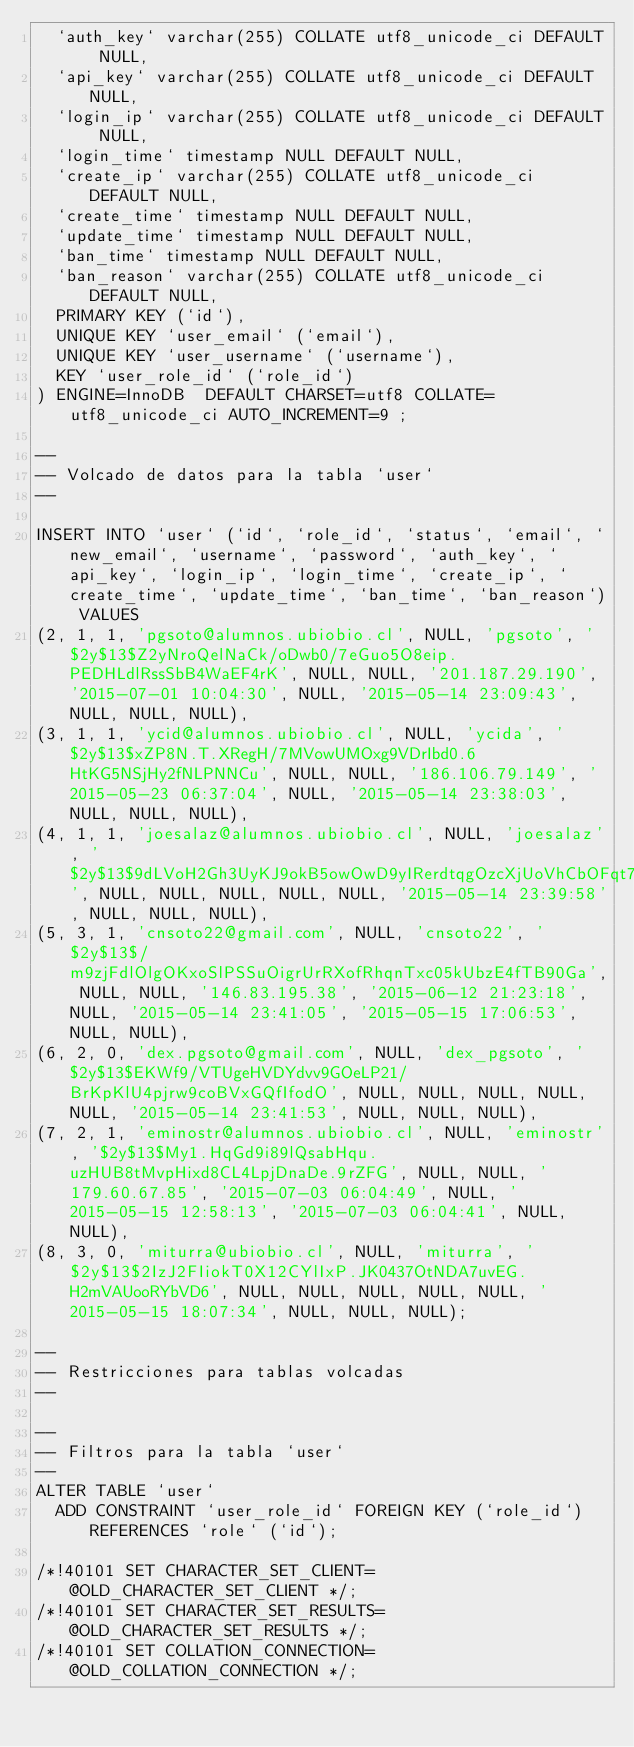Convert code to text. <code><loc_0><loc_0><loc_500><loc_500><_SQL_>  `auth_key` varchar(255) COLLATE utf8_unicode_ci DEFAULT NULL,
  `api_key` varchar(255) COLLATE utf8_unicode_ci DEFAULT NULL,
  `login_ip` varchar(255) COLLATE utf8_unicode_ci DEFAULT NULL,
  `login_time` timestamp NULL DEFAULT NULL,
  `create_ip` varchar(255) COLLATE utf8_unicode_ci DEFAULT NULL,
  `create_time` timestamp NULL DEFAULT NULL,
  `update_time` timestamp NULL DEFAULT NULL,
  `ban_time` timestamp NULL DEFAULT NULL,
  `ban_reason` varchar(255) COLLATE utf8_unicode_ci DEFAULT NULL,
  PRIMARY KEY (`id`),
  UNIQUE KEY `user_email` (`email`),
  UNIQUE KEY `user_username` (`username`),
  KEY `user_role_id` (`role_id`)
) ENGINE=InnoDB  DEFAULT CHARSET=utf8 COLLATE=utf8_unicode_ci AUTO_INCREMENT=9 ;

--
-- Volcado de datos para la tabla `user`
--

INSERT INTO `user` (`id`, `role_id`, `status`, `email`, `new_email`, `username`, `password`, `auth_key`, `api_key`, `login_ip`, `login_time`, `create_ip`, `create_time`, `update_time`, `ban_time`, `ban_reason`) VALUES
(2, 1, 1, 'pgsoto@alumnos.ubiobio.cl', NULL, 'pgsoto', '$2y$13$Z2yNroQelNaCk/oDwb0/7eGuo5O8eip.PEDHLdlRssSbB4WaEF4rK', NULL, NULL, '201.187.29.190', '2015-07-01 10:04:30', NULL, '2015-05-14 23:09:43', NULL, NULL, NULL),
(3, 1, 1, 'ycid@alumnos.ubiobio.cl', NULL, 'ycida', '$2y$13$xZP8N.T.XRegH/7MVowUMOxg9VDrIbd0.6HtKG5NSjHy2fNLPNNCu', NULL, NULL, '186.106.79.149', '2015-05-23 06:37:04', NULL, '2015-05-14 23:38:03', NULL, NULL, NULL),
(4, 1, 1, 'joesalaz@alumnos.ubiobio.cl', NULL, 'joesalaz', '$2y$13$9dLVoH2Gh3UyKJ9okB5owOwD9yIRerdtqgOzcXjUoVhCbOFqt7vH6', NULL, NULL, NULL, NULL, NULL, '2015-05-14 23:39:58', NULL, NULL, NULL),
(5, 3, 1, 'cnsoto22@gmail.com', NULL, 'cnsoto22', '$2y$13$/m9zjFdlOlgOKxoSlPSSuOigrUrRXofRhqnTxc05kUbzE4fTB90Ga', NULL, NULL, '146.83.195.38', '2015-06-12 21:23:18', NULL, '2015-05-14 23:41:05', '2015-05-15 17:06:53', NULL, NULL),
(6, 2, 0, 'dex.pgsoto@gmail.com', NULL, 'dex_pgsoto', '$2y$13$EKWf9/VTUgeHVDYdvv9GOeLP21/BrKpKlU4pjrw9coBVxGQfIfodO', NULL, NULL, NULL, NULL, NULL, '2015-05-14 23:41:53', NULL, NULL, NULL),
(7, 2, 1, 'eminostr@alumnos.ubiobio.cl', NULL, 'eminostr', '$2y$13$My1.HqGd9i89lQsabHqu.uzHUB8tMvpHixd8CL4LpjDnaDe.9rZFG', NULL, NULL, '179.60.67.85', '2015-07-03 06:04:49', NULL, '2015-05-15 12:58:13', '2015-07-03 06:04:41', NULL, NULL),
(8, 3, 0, 'miturra@ubiobio.cl', NULL, 'miturra', '$2y$13$2IzJ2FIiokT0X12CYlIxP.JK0437OtNDA7uvEG.H2mVAUooRYbVD6', NULL, NULL, NULL, NULL, NULL, '2015-05-15 18:07:34', NULL, NULL, NULL);

--
-- Restricciones para tablas volcadas
--

--
-- Filtros para la tabla `user`
--
ALTER TABLE `user`
  ADD CONSTRAINT `user_role_id` FOREIGN KEY (`role_id`) REFERENCES `role` (`id`);

/*!40101 SET CHARACTER_SET_CLIENT=@OLD_CHARACTER_SET_CLIENT */;
/*!40101 SET CHARACTER_SET_RESULTS=@OLD_CHARACTER_SET_RESULTS */;
/*!40101 SET COLLATION_CONNECTION=@OLD_COLLATION_CONNECTION */;
</code> 